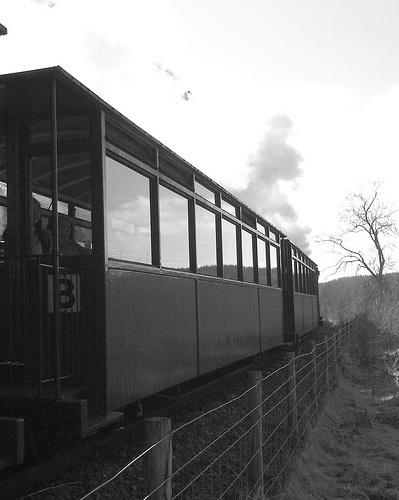What time of day does it appear to be in the photograph? It appears to be late afternoon, as indicated by the soft lighting and the shadows cast by the train and trees. 